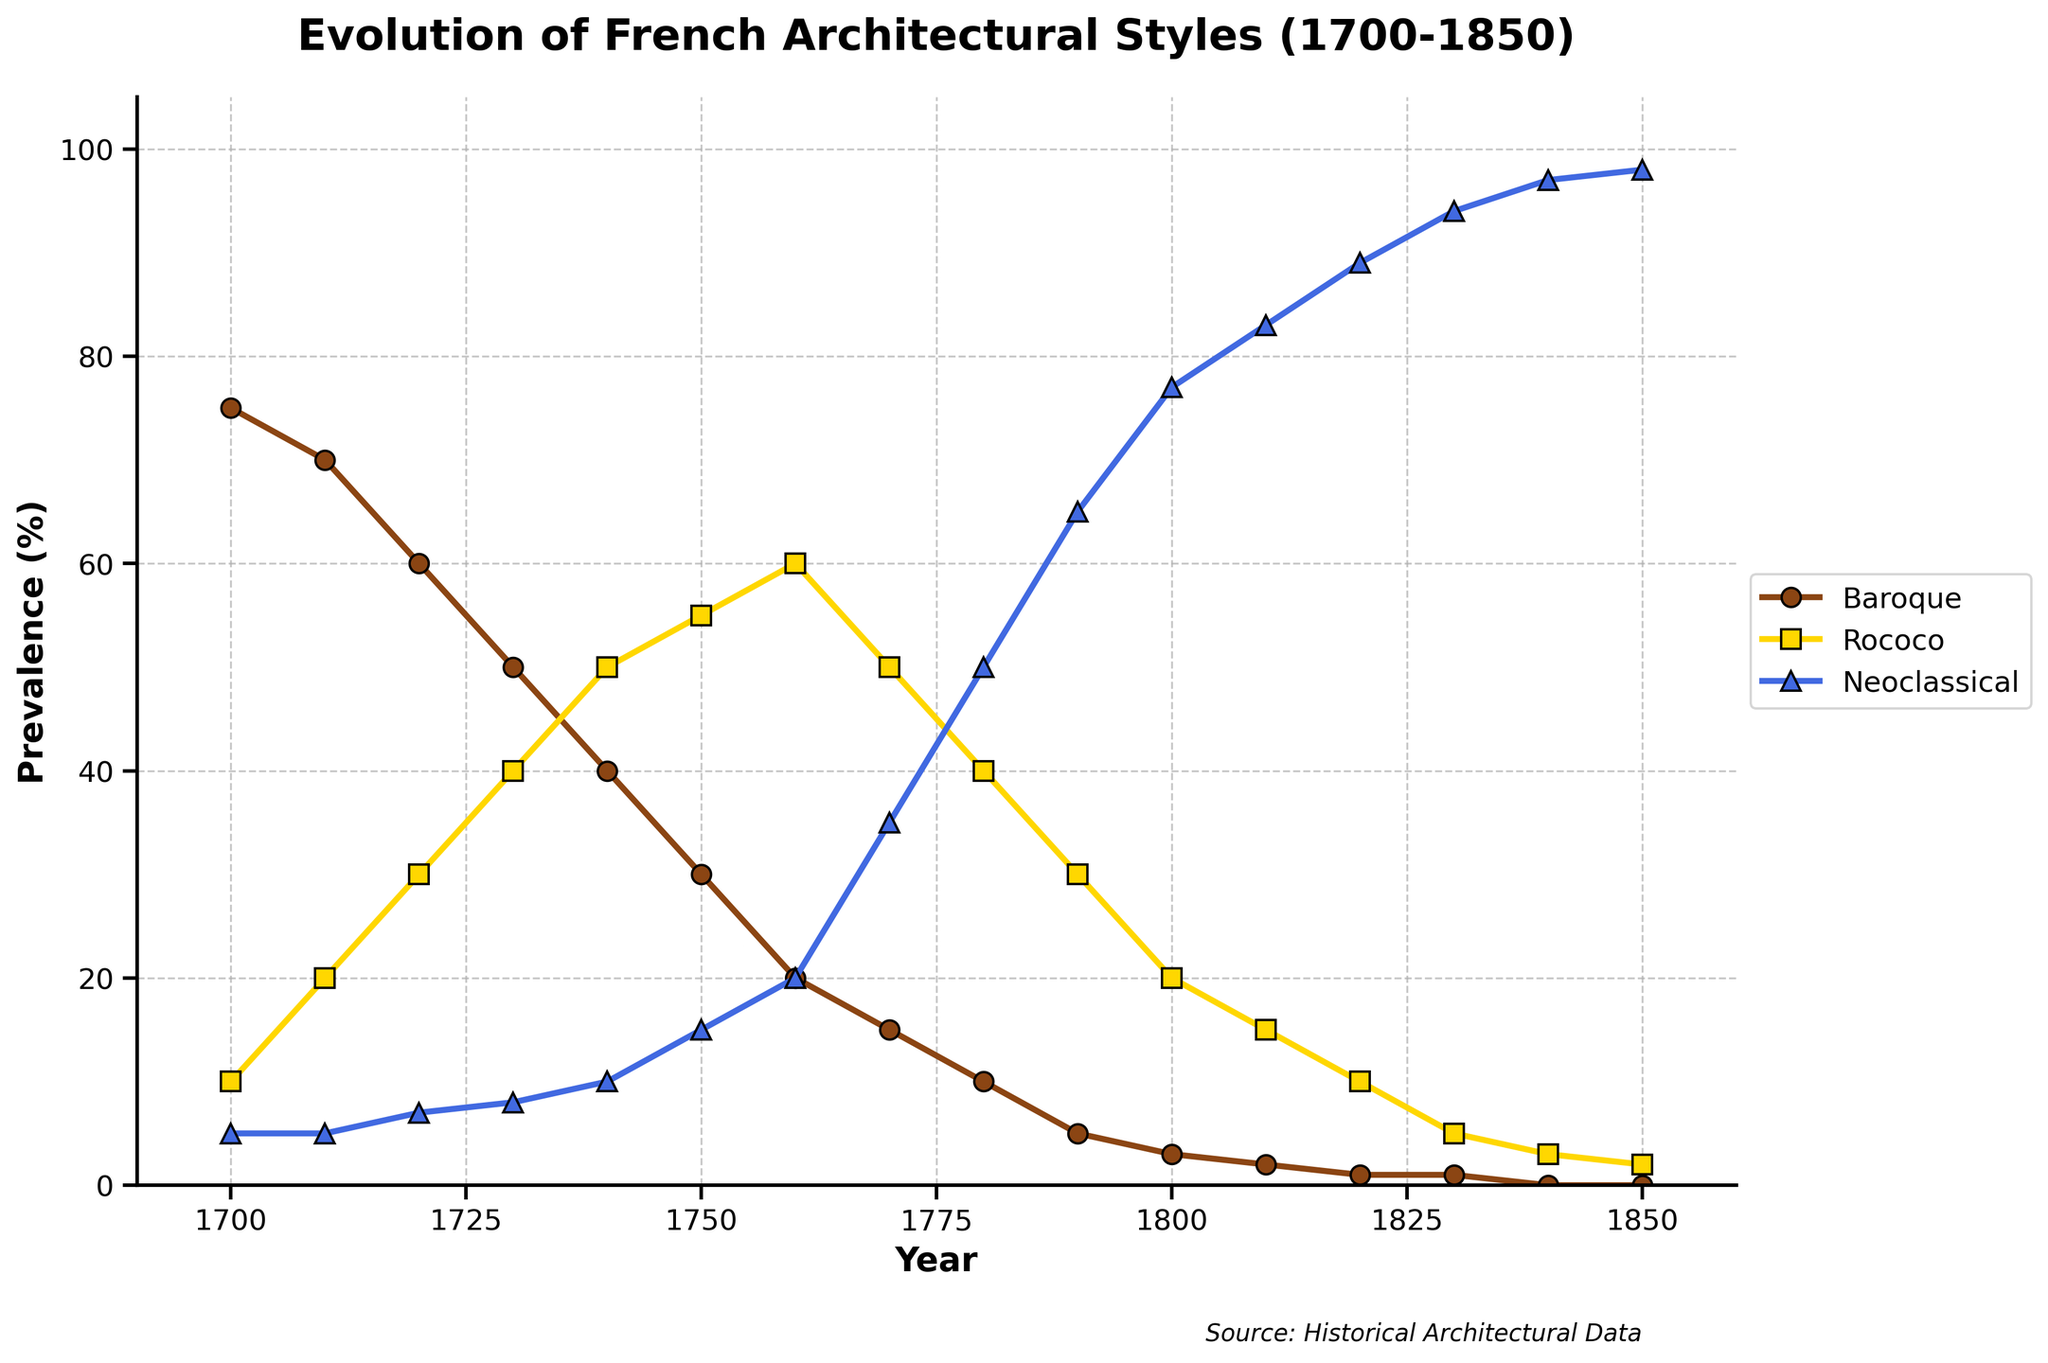When did Rococo style become more prevalent than Baroque style? Rococo style overtakes Baroque style between 1750 and 1760. Looking at the data, Rococo is 55% in 1750 and Baroque is 30%; by 1760, Rococo is 60% and Baroque is 20%. Therefore, the crossing point is just before 1760.
Answer: Shortly before 1760 Which architectural style had the highest prevalence at the end of the given period? In 1850, the Neoclassical style has a prevalence of 98%, Baroque is 0%, and Rococo is 2%.
Answer: Neoclassical Between 1700 and 1850, which style saw the most dramatic decline? Baroque declined from 75% in 1700 to 0% in 1850. Rococo and Neoclassical, on the other hand, increased in prevalence during this period.
Answer: Baroque What year marks the peak prevalence of Rococo style? Rococo peaks at 60% in 1760. Observing the data, the Rococo style's percentage increases until 1760 and then starts to decline.
Answer: 1760 By how much did the prevalence of Neoclassical style increase between 1700 and 1850? In 1700, Neoclassical rated at 5%; by 1850, it rose to 98%. The increase is calculated as 98 - 5 = 93.
Answer: 93% Compare the prevalence of Baroque and Rococo styles in 1740. Which one was higher? In 1740, Baroque had a prevalence of 40% and Rococo had 50%. Therefore, Rococo was higher.
Answer: Rococo What is the average prevalence of Neoclassical style from 1800 to 1850? The data points for Neoclassical style from 1800 to 1850 are 77, 83, 89, 94, 97, 98. Summing them up: 77 + 83 + 89 + 94 + 97 + 98 = 538. Dividing by the number of years (6): 538/6 ≈ 89.67
Answer: 89.67% How does the prevalence of Rococo style change from 1770 to 1780? In 1770, Rococo is at 50%, and by 1780, it is at 40%. The change is 40% - 50% = -10%.
Answer: Declines by 10% In which decade did Neoclassical style exceed 50% prevalence? In the 1780s, Neoclassical goes from 50% in 1780 to 65% in 1790. Thus, it exceeds 50% in this decade.
Answer: 1780s 